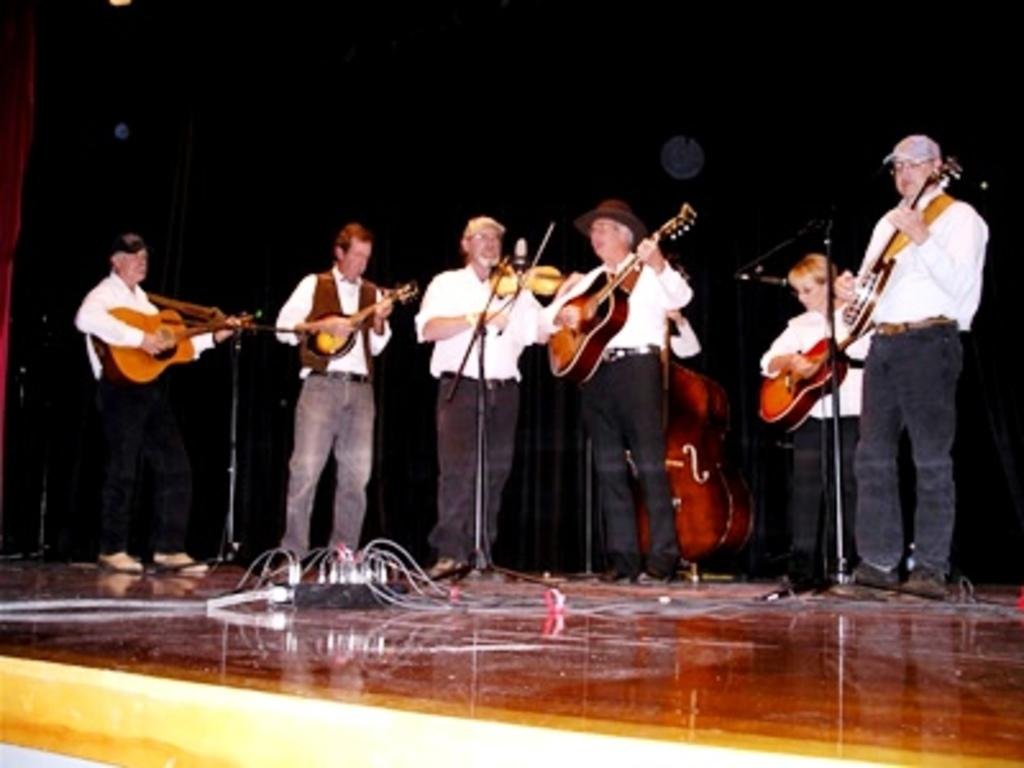What are the people in the image doing? The people in the image are standing and holding musical instruments. What might the people be about to do with the musical instruments? The people might be about to play music with the musical instruments. What is located in front of the people? There are mice in front of the people. What type of crack can be seen on the ground in the image? There is no crack visible on the ground in the image. 